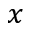<formula> <loc_0><loc_0><loc_500><loc_500>x</formula> 